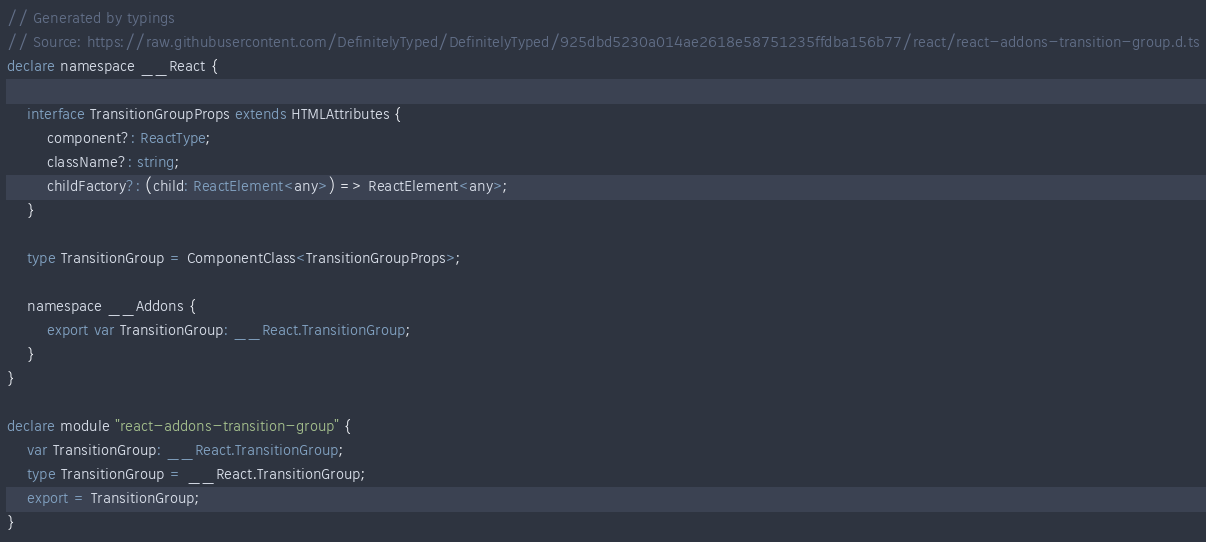Convert code to text. <code><loc_0><loc_0><loc_500><loc_500><_TypeScript_>// Generated by typings
// Source: https://raw.githubusercontent.com/DefinitelyTyped/DefinitelyTyped/925dbd5230a014ae2618e58751235ffdba156b77/react/react-addons-transition-group.d.ts
declare namespace __React {

    interface TransitionGroupProps extends HTMLAttributes {
        component?: ReactType;
        className?: string;
        childFactory?: (child: ReactElement<any>) => ReactElement<any>;
    }

    type TransitionGroup = ComponentClass<TransitionGroupProps>;

    namespace __Addons {
        export var TransitionGroup: __React.TransitionGroup;
    }
}

declare module "react-addons-transition-group" {
    var TransitionGroup: __React.TransitionGroup;
    type TransitionGroup = __React.TransitionGroup;
    export = TransitionGroup;
}</code> 